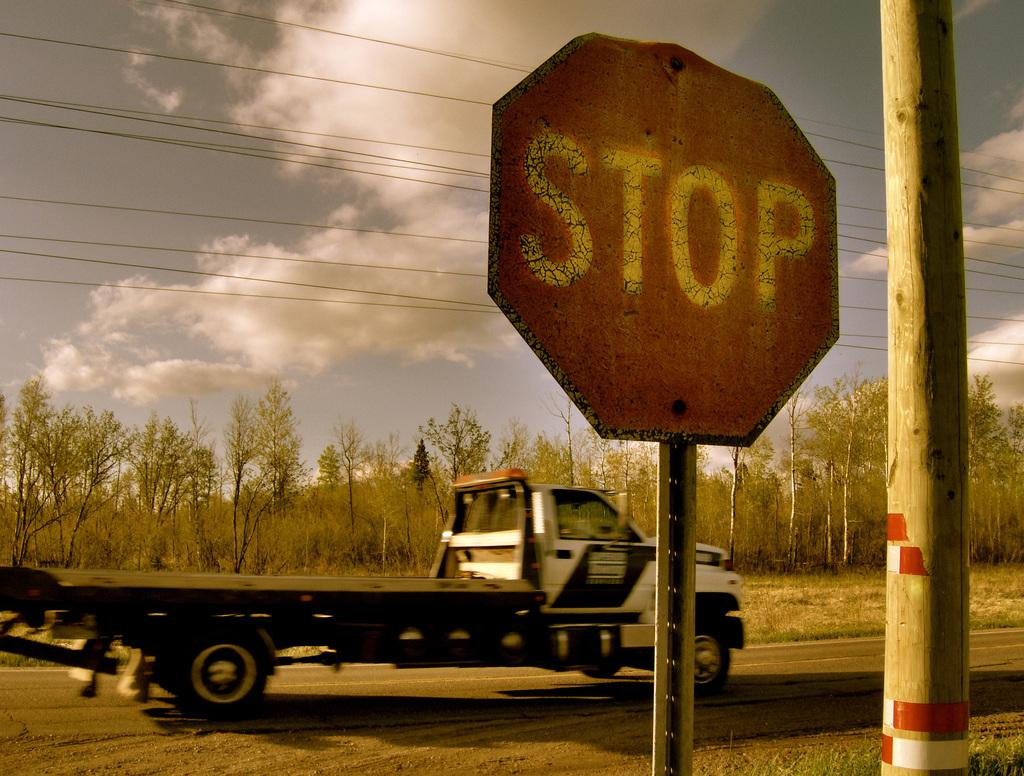<image>
Provide a brief description of the given image. A truck with a flat bed drives behind a stop sign. 